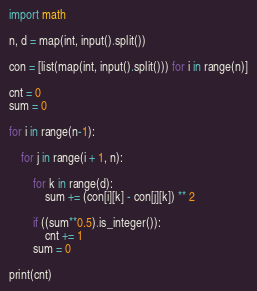Convert code to text. <code><loc_0><loc_0><loc_500><loc_500><_Python_>import math

n, d = map(int, input().split())

con = [list(map(int, input().split())) for i in range(n)]

cnt = 0
sum = 0

for i in range(n-1):

    for j in range(i + 1, n):

        for k in range(d):
            sum += (con[i][k] - con[j][k]) ** 2

        if ((sum**0.5).is_integer()):
            cnt += 1
        sum = 0

print(cnt)
</code> 